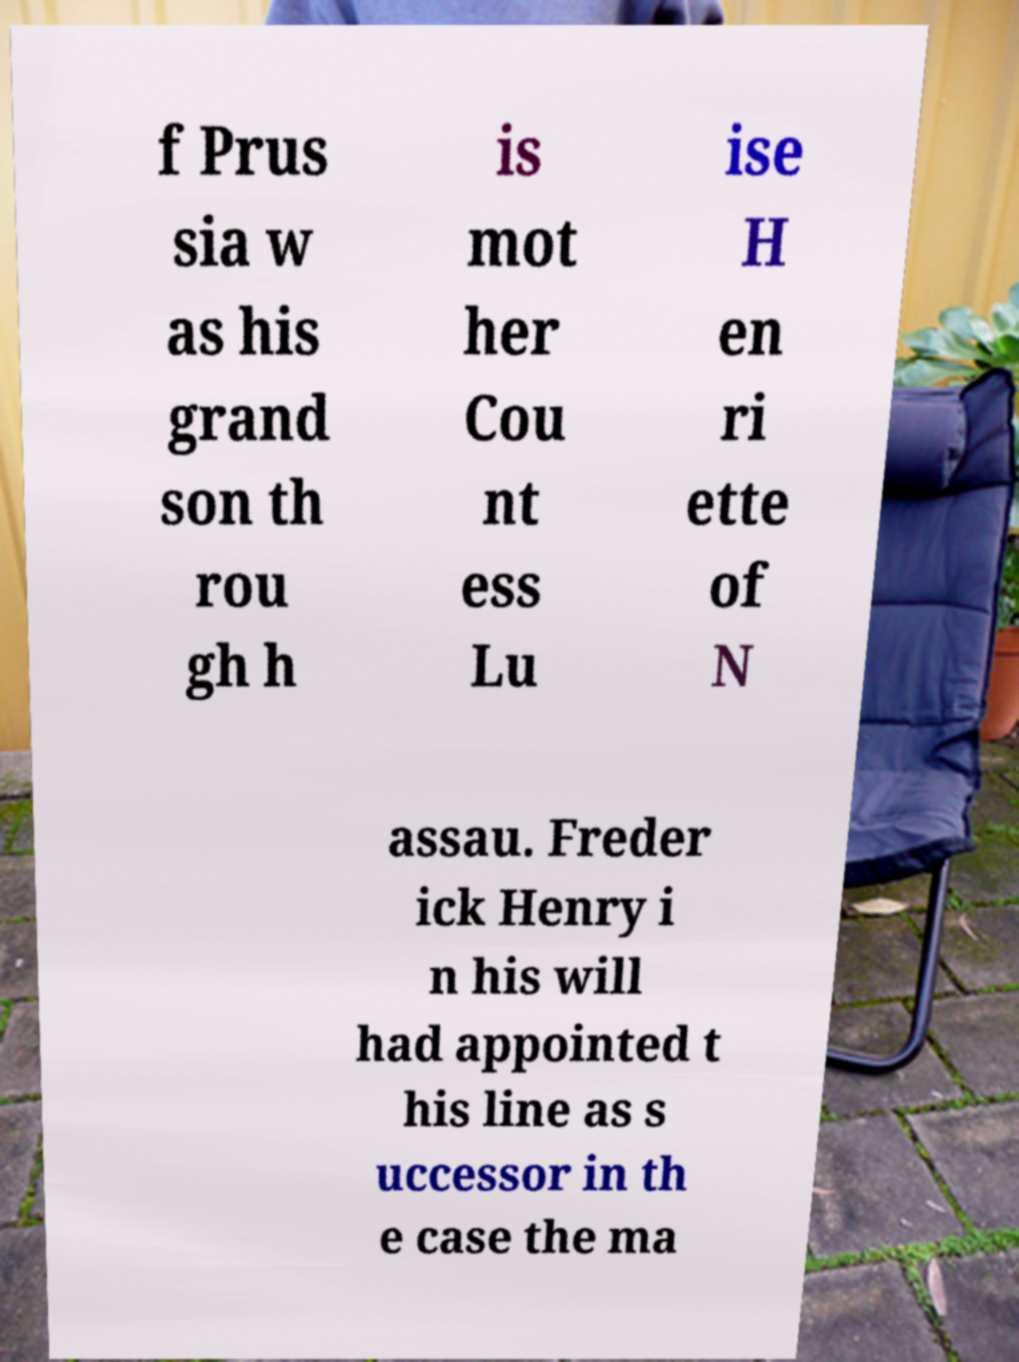There's text embedded in this image that I need extracted. Can you transcribe it verbatim? f Prus sia w as his grand son th rou gh h is mot her Cou nt ess Lu ise H en ri ette of N assau. Freder ick Henry i n his will had appointed t his line as s uccessor in th e case the ma 